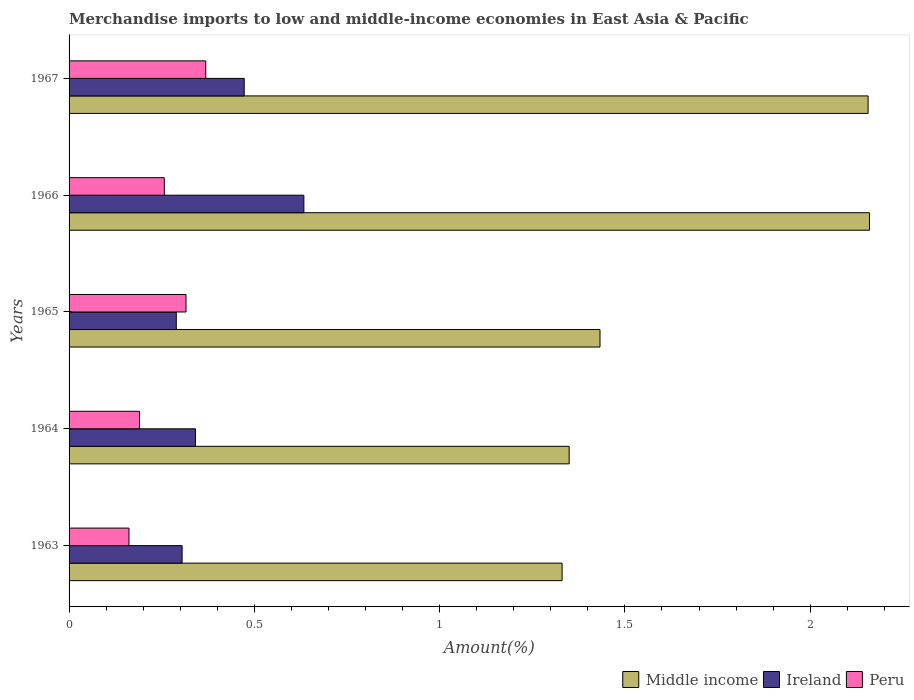How many groups of bars are there?
Offer a very short reply. 5. Are the number of bars per tick equal to the number of legend labels?
Your answer should be compact. Yes. Are the number of bars on each tick of the Y-axis equal?
Your answer should be compact. Yes. How many bars are there on the 4th tick from the top?
Your answer should be very brief. 3. What is the label of the 4th group of bars from the top?
Keep it short and to the point. 1964. In how many cases, is the number of bars for a given year not equal to the number of legend labels?
Provide a short and direct response. 0. What is the percentage of amount earned from merchandise imports in Middle income in 1964?
Give a very brief answer. 1.35. Across all years, what is the maximum percentage of amount earned from merchandise imports in Ireland?
Provide a short and direct response. 0.63. Across all years, what is the minimum percentage of amount earned from merchandise imports in Peru?
Your answer should be compact. 0.16. In which year was the percentage of amount earned from merchandise imports in Peru maximum?
Your answer should be compact. 1967. In which year was the percentage of amount earned from merchandise imports in Peru minimum?
Your answer should be compact. 1963. What is the total percentage of amount earned from merchandise imports in Peru in the graph?
Keep it short and to the point. 1.29. What is the difference between the percentage of amount earned from merchandise imports in Peru in 1963 and that in 1966?
Provide a short and direct response. -0.1. What is the difference between the percentage of amount earned from merchandise imports in Ireland in 1966 and the percentage of amount earned from merchandise imports in Peru in 1963?
Your answer should be very brief. 0.47. What is the average percentage of amount earned from merchandise imports in Peru per year?
Give a very brief answer. 0.26. In the year 1965, what is the difference between the percentage of amount earned from merchandise imports in Ireland and percentage of amount earned from merchandise imports in Middle income?
Your response must be concise. -1.14. In how many years, is the percentage of amount earned from merchandise imports in Peru greater than 2.1 %?
Make the answer very short. 0. What is the ratio of the percentage of amount earned from merchandise imports in Peru in 1963 to that in 1966?
Ensure brevity in your answer.  0.63. What is the difference between the highest and the second highest percentage of amount earned from merchandise imports in Peru?
Provide a short and direct response. 0.05. What is the difference between the highest and the lowest percentage of amount earned from merchandise imports in Ireland?
Your response must be concise. 0.34. In how many years, is the percentage of amount earned from merchandise imports in Peru greater than the average percentage of amount earned from merchandise imports in Peru taken over all years?
Your answer should be compact. 2. What does the 3rd bar from the top in 1964 represents?
Keep it short and to the point. Middle income. What does the 2nd bar from the bottom in 1963 represents?
Your answer should be very brief. Ireland. How many bars are there?
Your answer should be very brief. 15. Are all the bars in the graph horizontal?
Your response must be concise. Yes. Are the values on the major ticks of X-axis written in scientific E-notation?
Your answer should be compact. No. Does the graph contain any zero values?
Give a very brief answer. No. What is the title of the graph?
Provide a succinct answer. Merchandise imports to low and middle-income economies in East Asia & Pacific. Does "Sudan" appear as one of the legend labels in the graph?
Give a very brief answer. No. What is the label or title of the X-axis?
Give a very brief answer. Amount(%). What is the Amount(%) of Middle income in 1963?
Ensure brevity in your answer.  1.33. What is the Amount(%) of Ireland in 1963?
Your answer should be compact. 0.31. What is the Amount(%) of Peru in 1963?
Give a very brief answer. 0.16. What is the Amount(%) in Middle income in 1964?
Your answer should be very brief. 1.35. What is the Amount(%) in Ireland in 1964?
Make the answer very short. 0.34. What is the Amount(%) of Peru in 1964?
Offer a terse response. 0.19. What is the Amount(%) in Middle income in 1965?
Keep it short and to the point. 1.43. What is the Amount(%) of Ireland in 1965?
Make the answer very short. 0.29. What is the Amount(%) in Peru in 1965?
Offer a terse response. 0.32. What is the Amount(%) in Middle income in 1966?
Your response must be concise. 2.16. What is the Amount(%) of Ireland in 1966?
Your response must be concise. 0.63. What is the Amount(%) in Peru in 1966?
Provide a succinct answer. 0.26. What is the Amount(%) in Middle income in 1967?
Offer a terse response. 2.16. What is the Amount(%) of Ireland in 1967?
Your answer should be compact. 0.47. What is the Amount(%) of Peru in 1967?
Keep it short and to the point. 0.37. Across all years, what is the maximum Amount(%) of Middle income?
Offer a very short reply. 2.16. Across all years, what is the maximum Amount(%) in Ireland?
Give a very brief answer. 0.63. Across all years, what is the maximum Amount(%) in Peru?
Provide a succinct answer. 0.37. Across all years, what is the minimum Amount(%) of Middle income?
Keep it short and to the point. 1.33. Across all years, what is the minimum Amount(%) of Ireland?
Provide a succinct answer. 0.29. Across all years, what is the minimum Amount(%) in Peru?
Your answer should be very brief. 0.16. What is the total Amount(%) of Middle income in the graph?
Offer a terse response. 8.43. What is the total Amount(%) of Ireland in the graph?
Give a very brief answer. 2.04. What is the total Amount(%) of Peru in the graph?
Provide a short and direct response. 1.29. What is the difference between the Amount(%) of Middle income in 1963 and that in 1964?
Keep it short and to the point. -0.02. What is the difference between the Amount(%) of Ireland in 1963 and that in 1964?
Your answer should be very brief. -0.04. What is the difference between the Amount(%) in Peru in 1963 and that in 1964?
Your answer should be very brief. -0.03. What is the difference between the Amount(%) of Middle income in 1963 and that in 1965?
Provide a succinct answer. -0.1. What is the difference between the Amount(%) in Ireland in 1963 and that in 1965?
Provide a succinct answer. 0.02. What is the difference between the Amount(%) of Peru in 1963 and that in 1965?
Your answer should be very brief. -0.15. What is the difference between the Amount(%) in Middle income in 1963 and that in 1966?
Your answer should be compact. -0.83. What is the difference between the Amount(%) of Ireland in 1963 and that in 1966?
Keep it short and to the point. -0.33. What is the difference between the Amount(%) in Peru in 1963 and that in 1966?
Keep it short and to the point. -0.1. What is the difference between the Amount(%) in Middle income in 1963 and that in 1967?
Provide a short and direct response. -0.83. What is the difference between the Amount(%) of Ireland in 1963 and that in 1967?
Make the answer very short. -0.17. What is the difference between the Amount(%) in Peru in 1963 and that in 1967?
Offer a terse response. -0.21. What is the difference between the Amount(%) of Middle income in 1964 and that in 1965?
Give a very brief answer. -0.08. What is the difference between the Amount(%) in Ireland in 1964 and that in 1965?
Your answer should be compact. 0.05. What is the difference between the Amount(%) in Peru in 1964 and that in 1965?
Your response must be concise. -0.13. What is the difference between the Amount(%) of Middle income in 1964 and that in 1966?
Make the answer very short. -0.81. What is the difference between the Amount(%) in Ireland in 1964 and that in 1966?
Offer a terse response. -0.29. What is the difference between the Amount(%) in Peru in 1964 and that in 1966?
Provide a short and direct response. -0.07. What is the difference between the Amount(%) in Middle income in 1964 and that in 1967?
Your answer should be compact. -0.81. What is the difference between the Amount(%) in Ireland in 1964 and that in 1967?
Make the answer very short. -0.13. What is the difference between the Amount(%) in Peru in 1964 and that in 1967?
Offer a very short reply. -0.18. What is the difference between the Amount(%) of Middle income in 1965 and that in 1966?
Provide a succinct answer. -0.73. What is the difference between the Amount(%) of Ireland in 1965 and that in 1966?
Provide a succinct answer. -0.34. What is the difference between the Amount(%) of Peru in 1965 and that in 1966?
Keep it short and to the point. 0.06. What is the difference between the Amount(%) in Middle income in 1965 and that in 1967?
Offer a terse response. -0.72. What is the difference between the Amount(%) of Ireland in 1965 and that in 1967?
Offer a terse response. -0.18. What is the difference between the Amount(%) in Peru in 1965 and that in 1967?
Provide a succinct answer. -0.05. What is the difference between the Amount(%) of Middle income in 1966 and that in 1967?
Make the answer very short. 0. What is the difference between the Amount(%) of Ireland in 1966 and that in 1967?
Offer a terse response. 0.16. What is the difference between the Amount(%) of Peru in 1966 and that in 1967?
Provide a short and direct response. -0.11. What is the difference between the Amount(%) in Middle income in 1963 and the Amount(%) in Ireland in 1964?
Offer a very short reply. 0.99. What is the difference between the Amount(%) of Middle income in 1963 and the Amount(%) of Peru in 1964?
Ensure brevity in your answer.  1.14. What is the difference between the Amount(%) of Ireland in 1963 and the Amount(%) of Peru in 1964?
Provide a succinct answer. 0.12. What is the difference between the Amount(%) in Middle income in 1963 and the Amount(%) in Ireland in 1965?
Offer a terse response. 1.04. What is the difference between the Amount(%) in Ireland in 1963 and the Amount(%) in Peru in 1965?
Offer a very short reply. -0.01. What is the difference between the Amount(%) in Middle income in 1963 and the Amount(%) in Ireland in 1966?
Provide a short and direct response. 0.7. What is the difference between the Amount(%) of Middle income in 1963 and the Amount(%) of Peru in 1966?
Your answer should be very brief. 1.07. What is the difference between the Amount(%) in Ireland in 1963 and the Amount(%) in Peru in 1966?
Make the answer very short. 0.05. What is the difference between the Amount(%) of Middle income in 1963 and the Amount(%) of Ireland in 1967?
Provide a succinct answer. 0.86. What is the difference between the Amount(%) in Middle income in 1963 and the Amount(%) in Peru in 1967?
Make the answer very short. 0.96. What is the difference between the Amount(%) of Ireland in 1963 and the Amount(%) of Peru in 1967?
Give a very brief answer. -0.06. What is the difference between the Amount(%) of Middle income in 1964 and the Amount(%) of Ireland in 1965?
Make the answer very short. 1.06. What is the difference between the Amount(%) of Middle income in 1964 and the Amount(%) of Peru in 1965?
Offer a terse response. 1.03. What is the difference between the Amount(%) of Ireland in 1964 and the Amount(%) of Peru in 1965?
Keep it short and to the point. 0.03. What is the difference between the Amount(%) in Middle income in 1964 and the Amount(%) in Ireland in 1966?
Give a very brief answer. 0.72. What is the difference between the Amount(%) of Middle income in 1964 and the Amount(%) of Peru in 1966?
Your answer should be compact. 1.09. What is the difference between the Amount(%) in Ireland in 1964 and the Amount(%) in Peru in 1966?
Provide a short and direct response. 0.08. What is the difference between the Amount(%) of Middle income in 1964 and the Amount(%) of Ireland in 1967?
Ensure brevity in your answer.  0.88. What is the difference between the Amount(%) in Middle income in 1964 and the Amount(%) in Peru in 1967?
Your answer should be very brief. 0.98. What is the difference between the Amount(%) in Ireland in 1964 and the Amount(%) in Peru in 1967?
Keep it short and to the point. -0.03. What is the difference between the Amount(%) in Middle income in 1965 and the Amount(%) in Ireland in 1966?
Offer a terse response. 0.8. What is the difference between the Amount(%) in Middle income in 1965 and the Amount(%) in Peru in 1966?
Provide a succinct answer. 1.18. What is the difference between the Amount(%) in Ireland in 1965 and the Amount(%) in Peru in 1966?
Your response must be concise. 0.03. What is the difference between the Amount(%) in Middle income in 1965 and the Amount(%) in Ireland in 1967?
Offer a terse response. 0.96. What is the difference between the Amount(%) in Middle income in 1965 and the Amount(%) in Peru in 1967?
Provide a short and direct response. 1.06. What is the difference between the Amount(%) in Ireland in 1965 and the Amount(%) in Peru in 1967?
Your answer should be very brief. -0.08. What is the difference between the Amount(%) of Middle income in 1966 and the Amount(%) of Ireland in 1967?
Ensure brevity in your answer.  1.69. What is the difference between the Amount(%) in Middle income in 1966 and the Amount(%) in Peru in 1967?
Provide a short and direct response. 1.79. What is the difference between the Amount(%) of Ireland in 1966 and the Amount(%) of Peru in 1967?
Keep it short and to the point. 0.26. What is the average Amount(%) in Middle income per year?
Provide a succinct answer. 1.69. What is the average Amount(%) in Ireland per year?
Give a very brief answer. 0.41. What is the average Amount(%) of Peru per year?
Keep it short and to the point. 0.26. In the year 1963, what is the difference between the Amount(%) of Middle income and Amount(%) of Ireland?
Give a very brief answer. 1.03. In the year 1963, what is the difference between the Amount(%) in Middle income and Amount(%) in Peru?
Offer a terse response. 1.17. In the year 1963, what is the difference between the Amount(%) in Ireland and Amount(%) in Peru?
Your response must be concise. 0.14. In the year 1964, what is the difference between the Amount(%) in Middle income and Amount(%) in Ireland?
Provide a succinct answer. 1.01. In the year 1964, what is the difference between the Amount(%) of Middle income and Amount(%) of Peru?
Your answer should be compact. 1.16. In the year 1964, what is the difference between the Amount(%) of Ireland and Amount(%) of Peru?
Offer a very short reply. 0.15. In the year 1965, what is the difference between the Amount(%) in Middle income and Amount(%) in Ireland?
Your answer should be very brief. 1.14. In the year 1965, what is the difference between the Amount(%) in Middle income and Amount(%) in Peru?
Offer a terse response. 1.12. In the year 1965, what is the difference between the Amount(%) in Ireland and Amount(%) in Peru?
Provide a short and direct response. -0.03. In the year 1966, what is the difference between the Amount(%) in Middle income and Amount(%) in Ireland?
Your response must be concise. 1.53. In the year 1966, what is the difference between the Amount(%) of Middle income and Amount(%) of Peru?
Provide a short and direct response. 1.9. In the year 1966, what is the difference between the Amount(%) in Ireland and Amount(%) in Peru?
Give a very brief answer. 0.38. In the year 1967, what is the difference between the Amount(%) in Middle income and Amount(%) in Ireland?
Provide a succinct answer. 1.68. In the year 1967, what is the difference between the Amount(%) of Middle income and Amount(%) of Peru?
Offer a terse response. 1.79. In the year 1967, what is the difference between the Amount(%) of Ireland and Amount(%) of Peru?
Give a very brief answer. 0.1. What is the ratio of the Amount(%) in Middle income in 1963 to that in 1964?
Your answer should be very brief. 0.99. What is the ratio of the Amount(%) of Ireland in 1963 to that in 1964?
Provide a succinct answer. 0.89. What is the ratio of the Amount(%) of Peru in 1963 to that in 1964?
Ensure brevity in your answer.  0.85. What is the ratio of the Amount(%) of Middle income in 1963 to that in 1965?
Your response must be concise. 0.93. What is the ratio of the Amount(%) of Ireland in 1963 to that in 1965?
Offer a very short reply. 1.05. What is the ratio of the Amount(%) of Peru in 1963 to that in 1965?
Your answer should be very brief. 0.51. What is the ratio of the Amount(%) of Middle income in 1963 to that in 1966?
Ensure brevity in your answer.  0.62. What is the ratio of the Amount(%) in Ireland in 1963 to that in 1966?
Provide a succinct answer. 0.48. What is the ratio of the Amount(%) of Peru in 1963 to that in 1966?
Offer a very short reply. 0.63. What is the ratio of the Amount(%) in Middle income in 1963 to that in 1967?
Offer a terse response. 0.62. What is the ratio of the Amount(%) of Ireland in 1963 to that in 1967?
Your answer should be very brief. 0.65. What is the ratio of the Amount(%) of Peru in 1963 to that in 1967?
Ensure brevity in your answer.  0.44. What is the ratio of the Amount(%) in Middle income in 1964 to that in 1965?
Offer a terse response. 0.94. What is the ratio of the Amount(%) of Ireland in 1964 to that in 1965?
Your answer should be compact. 1.18. What is the ratio of the Amount(%) of Peru in 1964 to that in 1965?
Give a very brief answer. 0.6. What is the ratio of the Amount(%) of Middle income in 1964 to that in 1966?
Your response must be concise. 0.62. What is the ratio of the Amount(%) in Ireland in 1964 to that in 1966?
Your answer should be very brief. 0.54. What is the ratio of the Amount(%) of Peru in 1964 to that in 1966?
Ensure brevity in your answer.  0.74. What is the ratio of the Amount(%) of Middle income in 1964 to that in 1967?
Your answer should be very brief. 0.63. What is the ratio of the Amount(%) in Ireland in 1964 to that in 1967?
Give a very brief answer. 0.72. What is the ratio of the Amount(%) of Peru in 1964 to that in 1967?
Your answer should be compact. 0.52. What is the ratio of the Amount(%) of Middle income in 1965 to that in 1966?
Your response must be concise. 0.66. What is the ratio of the Amount(%) in Ireland in 1965 to that in 1966?
Give a very brief answer. 0.46. What is the ratio of the Amount(%) in Peru in 1965 to that in 1966?
Your response must be concise. 1.23. What is the ratio of the Amount(%) in Middle income in 1965 to that in 1967?
Ensure brevity in your answer.  0.66. What is the ratio of the Amount(%) in Ireland in 1965 to that in 1967?
Your answer should be compact. 0.61. What is the ratio of the Amount(%) in Peru in 1965 to that in 1967?
Your answer should be very brief. 0.86. What is the ratio of the Amount(%) in Ireland in 1966 to that in 1967?
Provide a short and direct response. 1.34. What is the ratio of the Amount(%) of Peru in 1966 to that in 1967?
Offer a terse response. 0.7. What is the difference between the highest and the second highest Amount(%) in Middle income?
Your response must be concise. 0. What is the difference between the highest and the second highest Amount(%) of Ireland?
Your answer should be very brief. 0.16. What is the difference between the highest and the second highest Amount(%) in Peru?
Your answer should be compact. 0.05. What is the difference between the highest and the lowest Amount(%) in Middle income?
Your response must be concise. 0.83. What is the difference between the highest and the lowest Amount(%) of Ireland?
Your answer should be compact. 0.34. What is the difference between the highest and the lowest Amount(%) in Peru?
Offer a terse response. 0.21. 